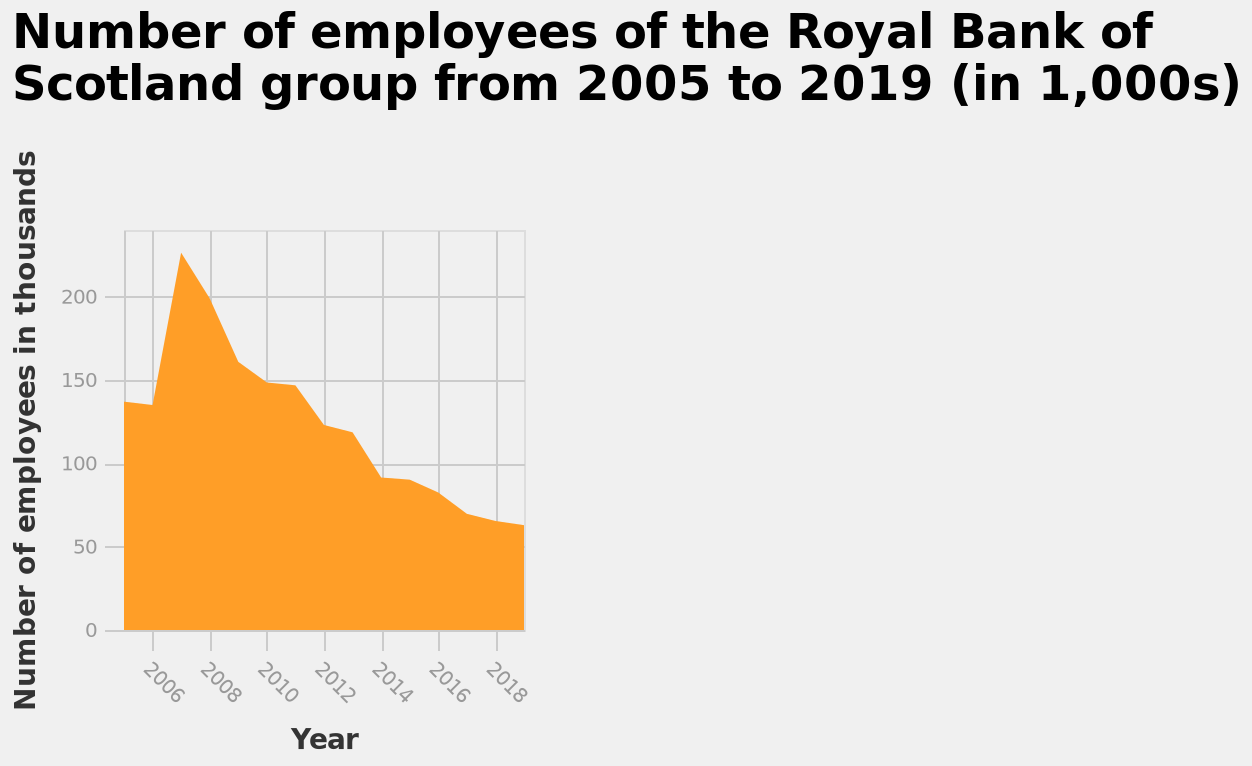<image>
What is the current trend in the number of employees at the Royal Bank of Scotland?  The current trend in the number of employees at the Royal Bank of Scotland is downward. What is the range of the x-axis? The range of the x-axis is from the year 2006 to 2018. What does the y-axis represent? The y-axis represents the Number of employees in thousands, with a scale ranging from 0 to 200. Is the Royal Bank of Scotland hiring or laying off employees?  The Royal Bank of Scotland is laying off employees. 